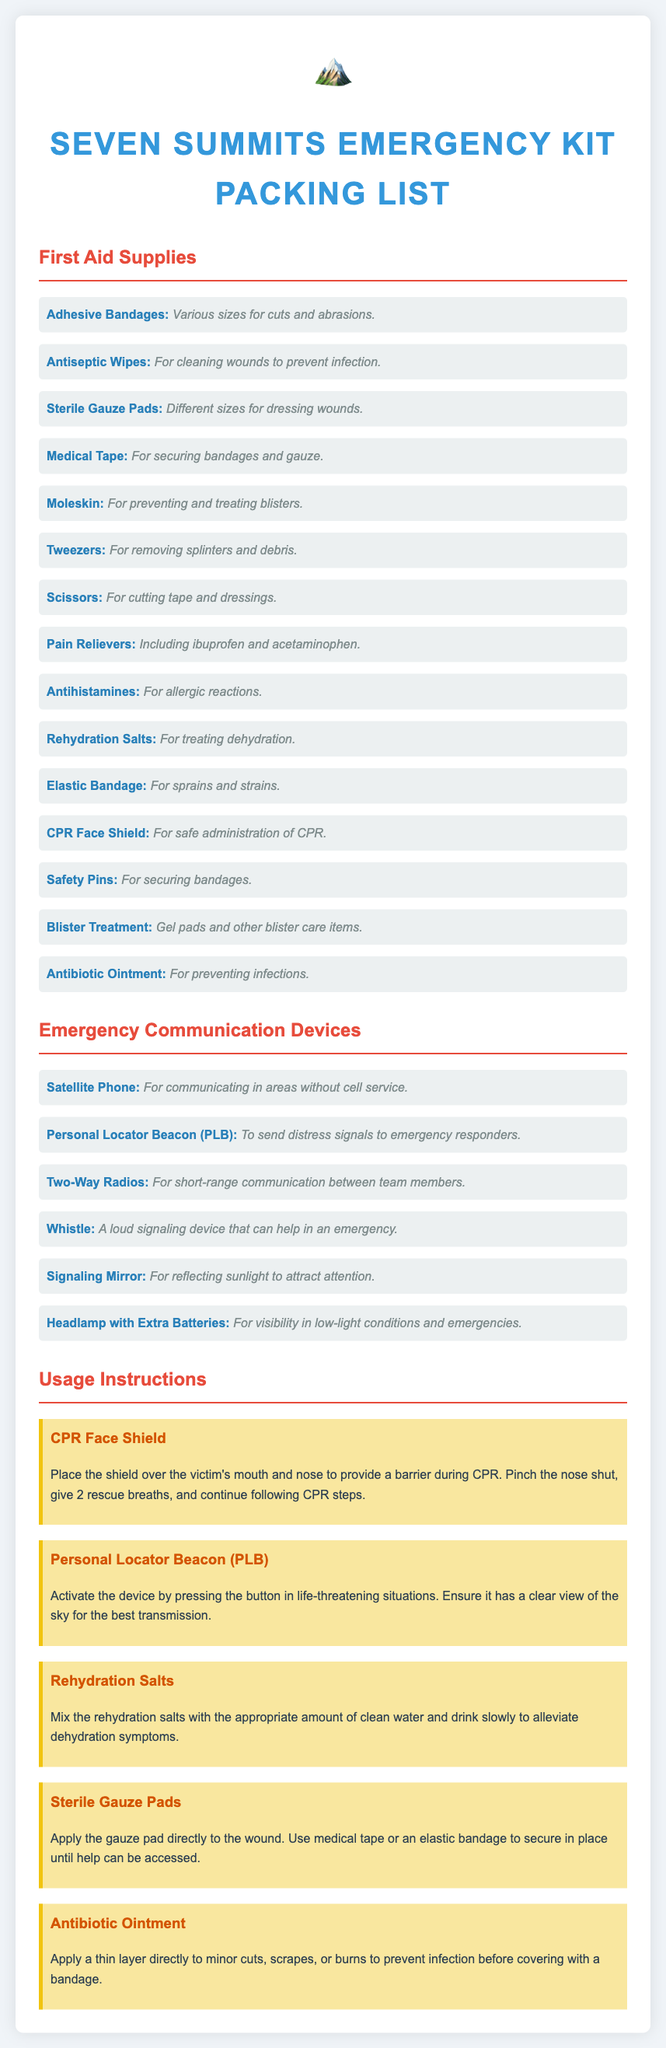What is the purpose of adhesive bandages? Adhesive bandages are for cuts and abrasions.
Answer: Cuts and abrasions How many types of emergency communication devices are listed? The document lists six emergency communication devices.
Answer: Six What should you mix with rehydration salts? You should mix rehydration salts with clean water.
Answer: Clean water What is the main use of antiseptic wipes? Antiseptic wipes are for cleaning wounds to prevent infection.
Answer: Cleaning wounds What does the CPR face shield provide? The CPR face shield provides a barrier during CPR.
Answer: A barrier Which device sends distress signals to emergency responders? The Personal Locator Beacon (PLB) sends distress signals.
Answer: Personal Locator Beacon (PLB) What is the size of sterile gauze pads mentioned? Different sizes for dressing wounds are mentioned.
Answer: Different sizes What can be used for preventing and treating blisters? Moleskin can be used for preventing and treating blisters.
Answer: Moleskin What color is the heading for First Aid Supplies? The heading for First Aid Supplies is blue.
Answer: Blue 